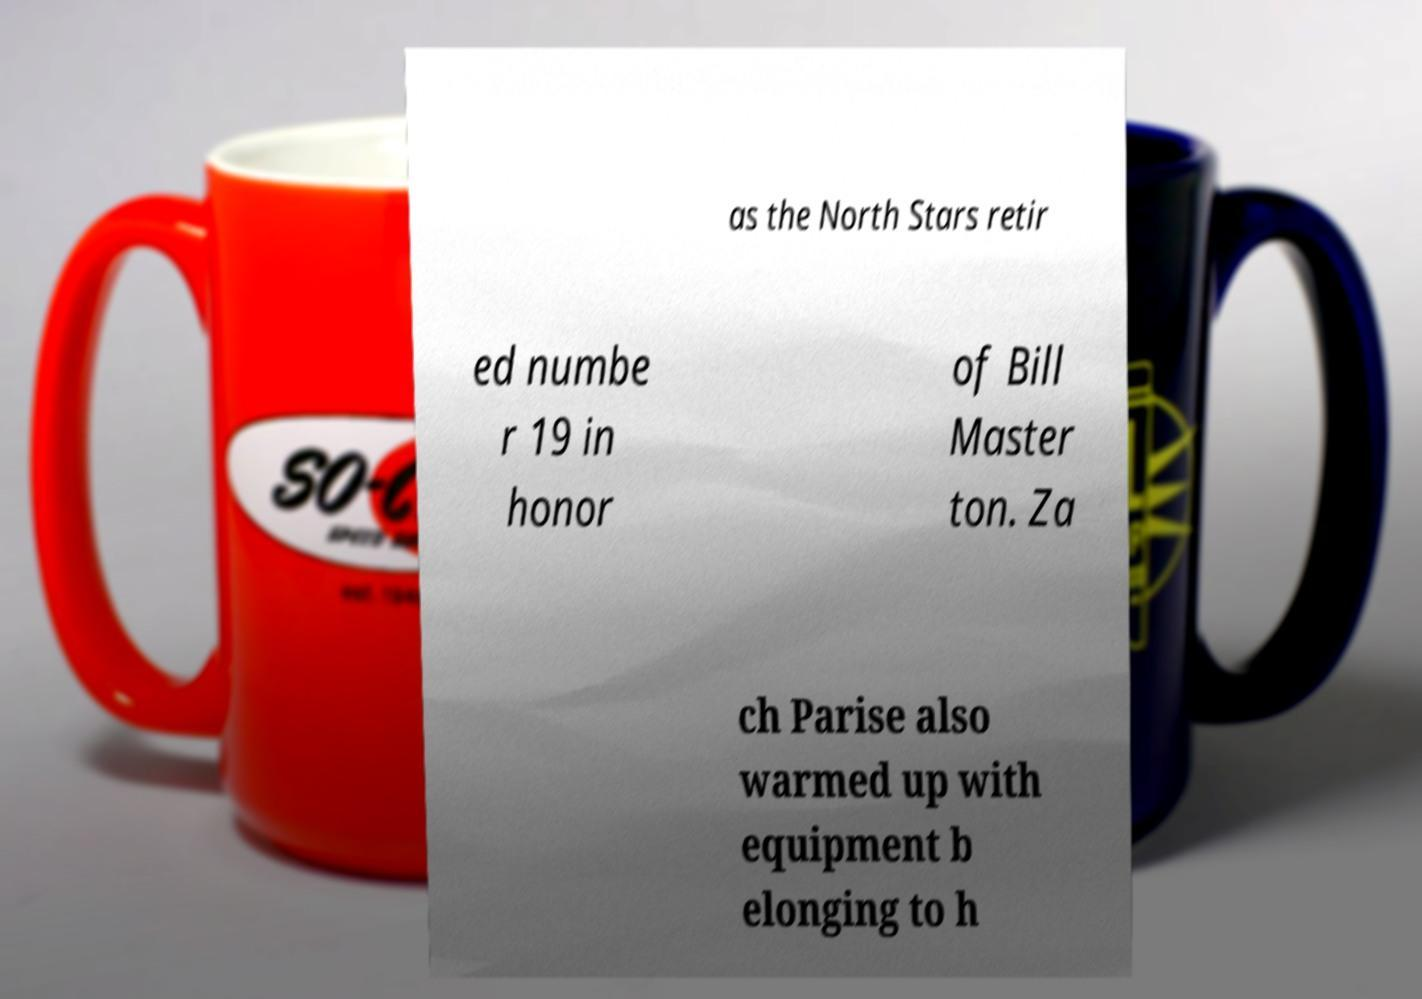I need the written content from this picture converted into text. Can you do that? as the North Stars retir ed numbe r 19 in honor of Bill Master ton. Za ch Parise also warmed up with equipment b elonging to h 